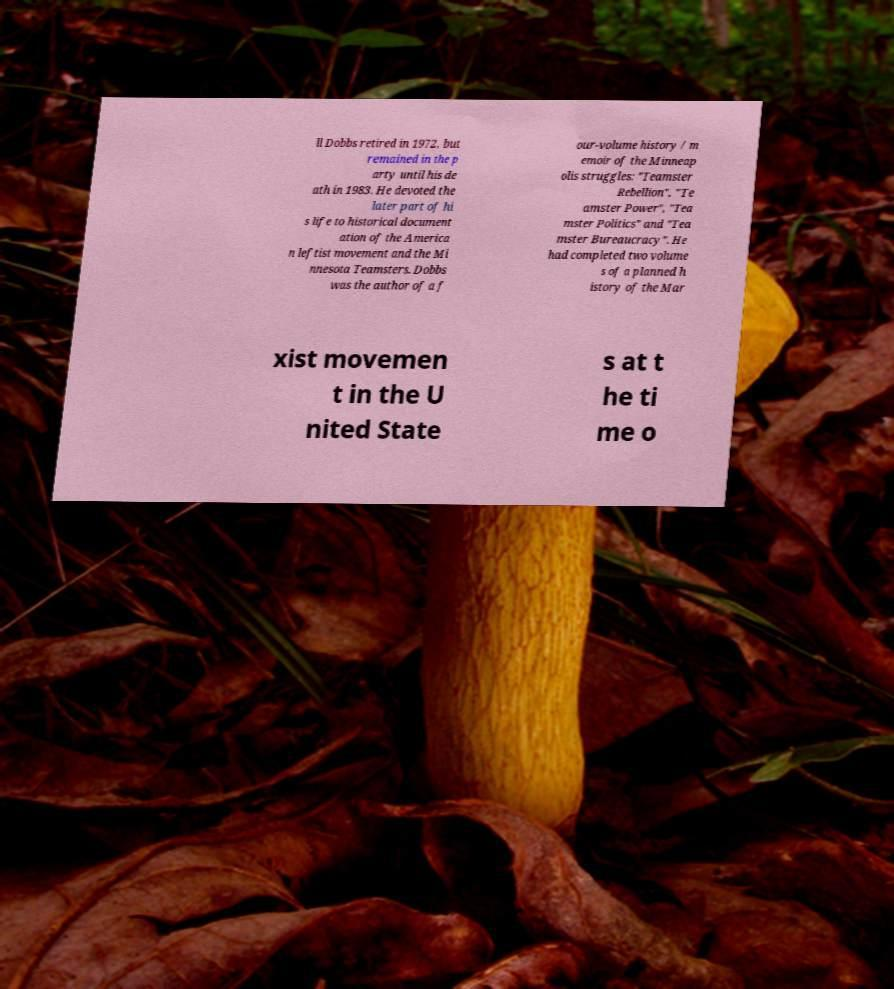Could you extract and type out the text from this image? ll Dobbs retired in 1972, but remained in the p arty until his de ath in 1983. He devoted the later part of hi s life to historical document ation of the America n leftist movement and the Mi nnesota Teamsters. Dobbs was the author of a f our-volume history / m emoir of the Minneap olis struggles: "Teamster Rebellion", "Te amster Power", "Tea mster Politics" and "Tea mster Bureaucracy". He had completed two volume s of a planned h istory of the Mar xist movemen t in the U nited State s at t he ti me o 